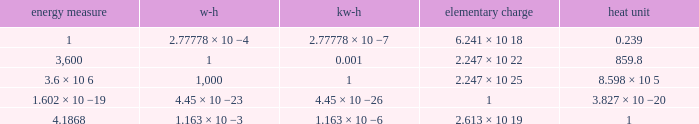How many electronvolts is 3,600 joules? 2.247 × 10 22. 